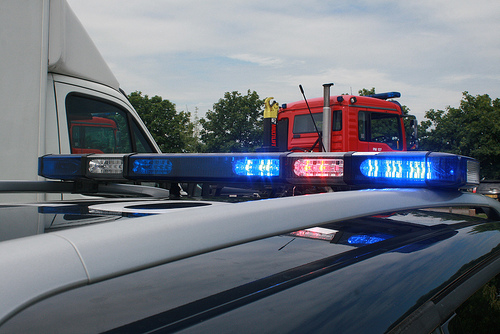<image>
Is the blue light on the truck? No. The blue light is not positioned on the truck. They may be near each other, but the blue light is not supported by or resting on top of the truck. 